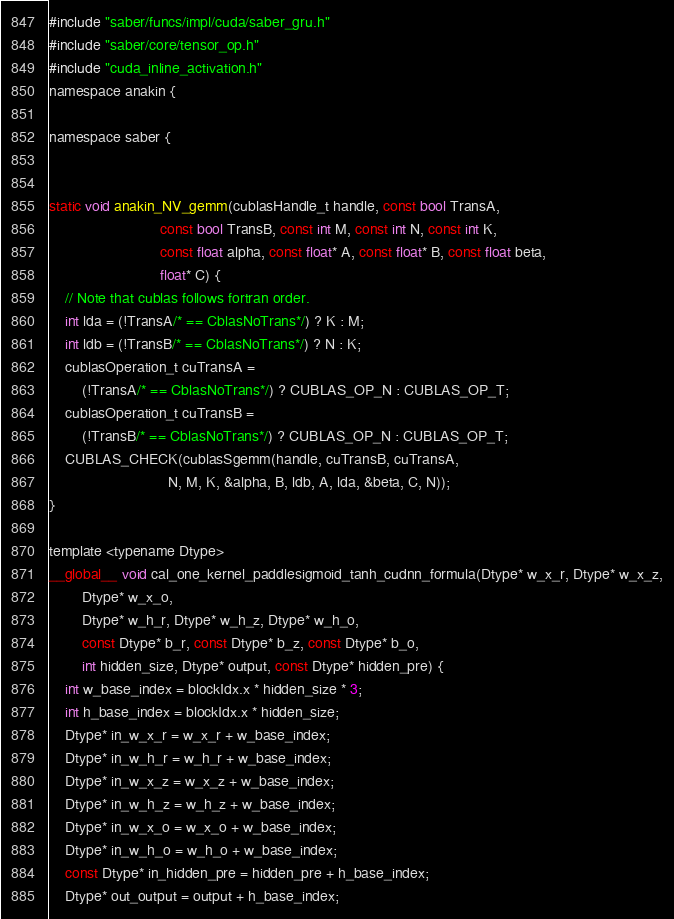Convert code to text. <code><loc_0><loc_0><loc_500><loc_500><_Cuda_>#include "saber/funcs/impl/cuda/saber_gru.h"
#include "saber/core/tensor_op.h"
#include "cuda_inline_activation.h"
namespace anakin {

namespace saber {


static void anakin_NV_gemm(cublasHandle_t handle, const bool TransA,
                           const bool TransB, const int M, const int N, const int K,
                           const float alpha, const float* A, const float* B, const float beta,
                           float* C) {
    // Note that cublas follows fortran order.
    int lda = (!TransA/* == CblasNoTrans*/) ? K : M;
    int ldb = (!TransB/* == CblasNoTrans*/) ? N : K;
    cublasOperation_t cuTransA =
        (!TransA/* == CblasNoTrans*/) ? CUBLAS_OP_N : CUBLAS_OP_T;
    cublasOperation_t cuTransB =
        (!TransB/* == CblasNoTrans*/) ? CUBLAS_OP_N : CUBLAS_OP_T;
    CUBLAS_CHECK(cublasSgemm(handle, cuTransB, cuTransA,
                             N, M, K, &alpha, B, ldb, A, lda, &beta, C, N));
}

template <typename Dtype>
__global__ void cal_one_kernel_paddlesigmoid_tanh_cudnn_formula(Dtype* w_x_r, Dtype* w_x_z,
        Dtype* w_x_o,
        Dtype* w_h_r, Dtype* w_h_z, Dtype* w_h_o,
        const Dtype* b_r, const Dtype* b_z, const Dtype* b_o,
        int hidden_size, Dtype* output, const Dtype* hidden_pre) {
    int w_base_index = blockIdx.x * hidden_size * 3;
    int h_base_index = blockIdx.x * hidden_size;
    Dtype* in_w_x_r = w_x_r + w_base_index;
    Dtype* in_w_h_r = w_h_r + w_base_index;
    Dtype* in_w_x_z = w_x_z + w_base_index;
    Dtype* in_w_h_z = w_h_z + w_base_index;
    Dtype* in_w_x_o = w_x_o + w_base_index;
    Dtype* in_w_h_o = w_h_o + w_base_index;
    const Dtype* in_hidden_pre = hidden_pre + h_base_index;
    Dtype* out_output = output + h_base_index;
</code> 